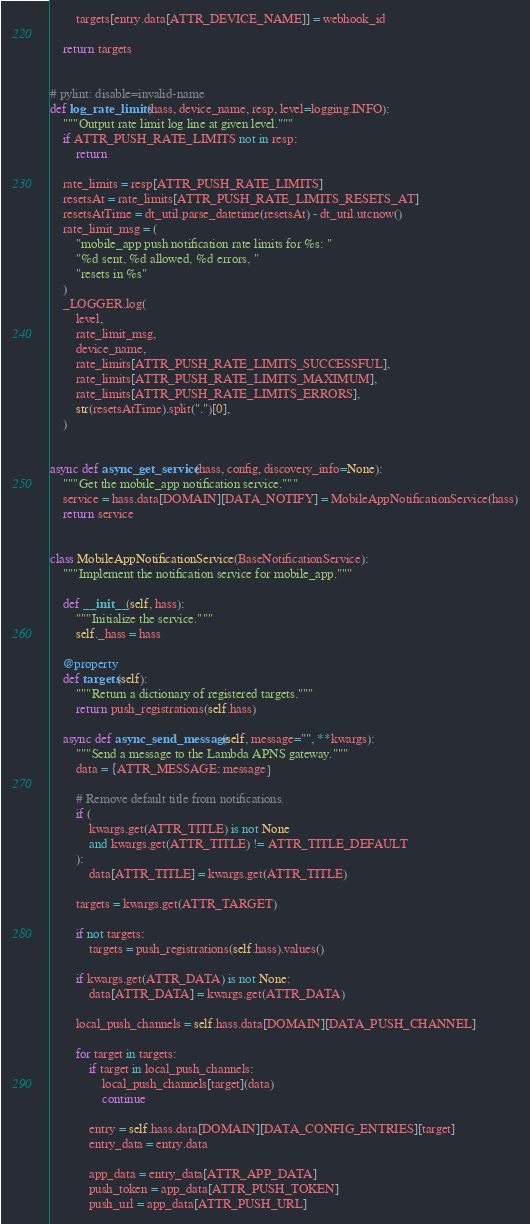<code> <loc_0><loc_0><loc_500><loc_500><_Python_>
        targets[entry.data[ATTR_DEVICE_NAME]] = webhook_id

    return targets


# pylint: disable=invalid-name
def log_rate_limits(hass, device_name, resp, level=logging.INFO):
    """Output rate limit log line at given level."""
    if ATTR_PUSH_RATE_LIMITS not in resp:
        return

    rate_limits = resp[ATTR_PUSH_RATE_LIMITS]
    resetsAt = rate_limits[ATTR_PUSH_RATE_LIMITS_RESETS_AT]
    resetsAtTime = dt_util.parse_datetime(resetsAt) - dt_util.utcnow()
    rate_limit_msg = (
        "mobile_app push notification rate limits for %s: "
        "%d sent, %d allowed, %d errors, "
        "resets in %s"
    )
    _LOGGER.log(
        level,
        rate_limit_msg,
        device_name,
        rate_limits[ATTR_PUSH_RATE_LIMITS_SUCCESSFUL],
        rate_limits[ATTR_PUSH_RATE_LIMITS_MAXIMUM],
        rate_limits[ATTR_PUSH_RATE_LIMITS_ERRORS],
        str(resetsAtTime).split(".")[0],
    )


async def async_get_service(hass, config, discovery_info=None):
    """Get the mobile_app notification service."""
    service = hass.data[DOMAIN][DATA_NOTIFY] = MobileAppNotificationService(hass)
    return service


class MobileAppNotificationService(BaseNotificationService):
    """Implement the notification service for mobile_app."""

    def __init__(self, hass):
        """Initialize the service."""
        self._hass = hass

    @property
    def targets(self):
        """Return a dictionary of registered targets."""
        return push_registrations(self.hass)

    async def async_send_message(self, message="", **kwargs):
        """Send a message to the Lambda APNS gateway."""
        data = {ATTR_MESSAGE: message}

        # Remove default title from notifications.
        if (
            kwargs.get(ATTR_TITLE) is not None
            and kwargs.get(ATTR_TITLE) != ATTR_TITLE_DEFAULT
        ):
            data[ATTR_TITLE] = kwargs.get(ATTR_TITLE)

        targets = kwargs.get(ATTR_TARGET)

        if not targets:
            targets = push_registrations(self.hass).values()

        if kwargs.get(ATTR_DATA) is not None:
            data[ATTR_DATA] = kwargs.get(ATTR_DATA)

        local_push_channels = self.hass.data[DOMAIN][DATA_PUSH_CHANNEL]

        for target in targets:
            if target in local_push_channels:
                local_push_channels[target](data)
                continue

            entry = self.hass.data[DOMAIN][DATA_CONFIG_ENTRIES][target]
            entry_data = entry.data

            app_data = entry_data[ATTR_APP_DATA]
            push_token = app_data[ATTR_PUSH_TOKEN]
            push_url = app_data[ATTR_PUSH_URL]
</code> 